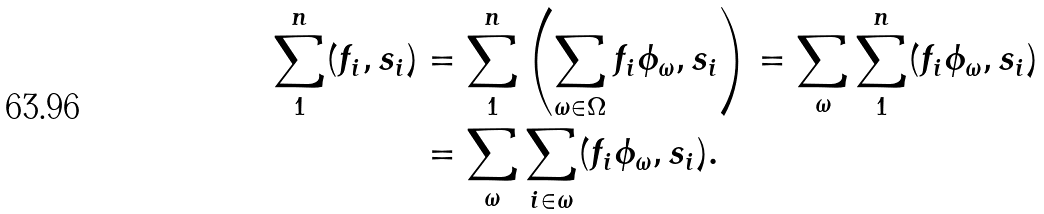<formula> <loc_0><loc_0><loc_500><loc_500>\sum _ { 1 } ^ { n } ( f _ { i } , s _ { i } ) & = \sum _ { 1 } ^ { n } \left ( \sum _ { \omega \in \Omega } f _ { i } \phi _ { \omega } , s _ { i } \right ) = \sum _ { \omega } \sum _ { 1 } ^ { n } ( f _ { i } \phi _ { \omega } , s _ { i } ) \\ & = \sum _ { \omega } \sum _ { i \in \omega } ( f _ { i } \phi _ { \omega } , s _ { i } ) .</formula> 